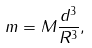Convert formula to latex. <formula><loc_0><loc_0><loc_500><loc_500>m = M \frac { d ^ { 3 } } { R ^ { 3 } } ,</formula> 